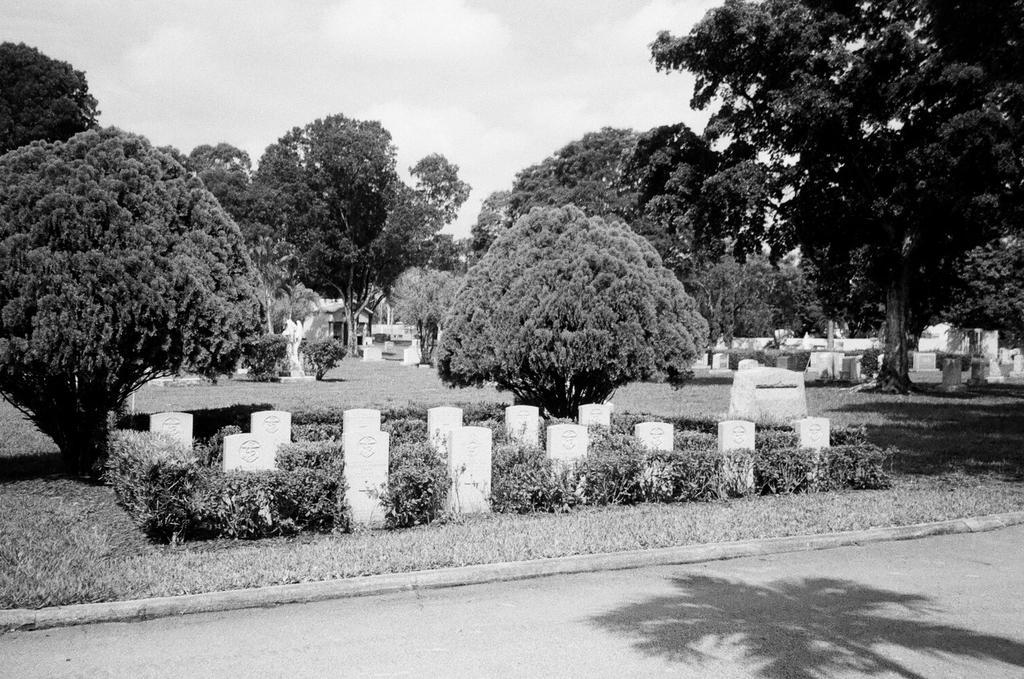Describe this image in one or two sentences. In this image we can see a graveyard, with some graves, plants, trees, grass, also we can see the sky. 